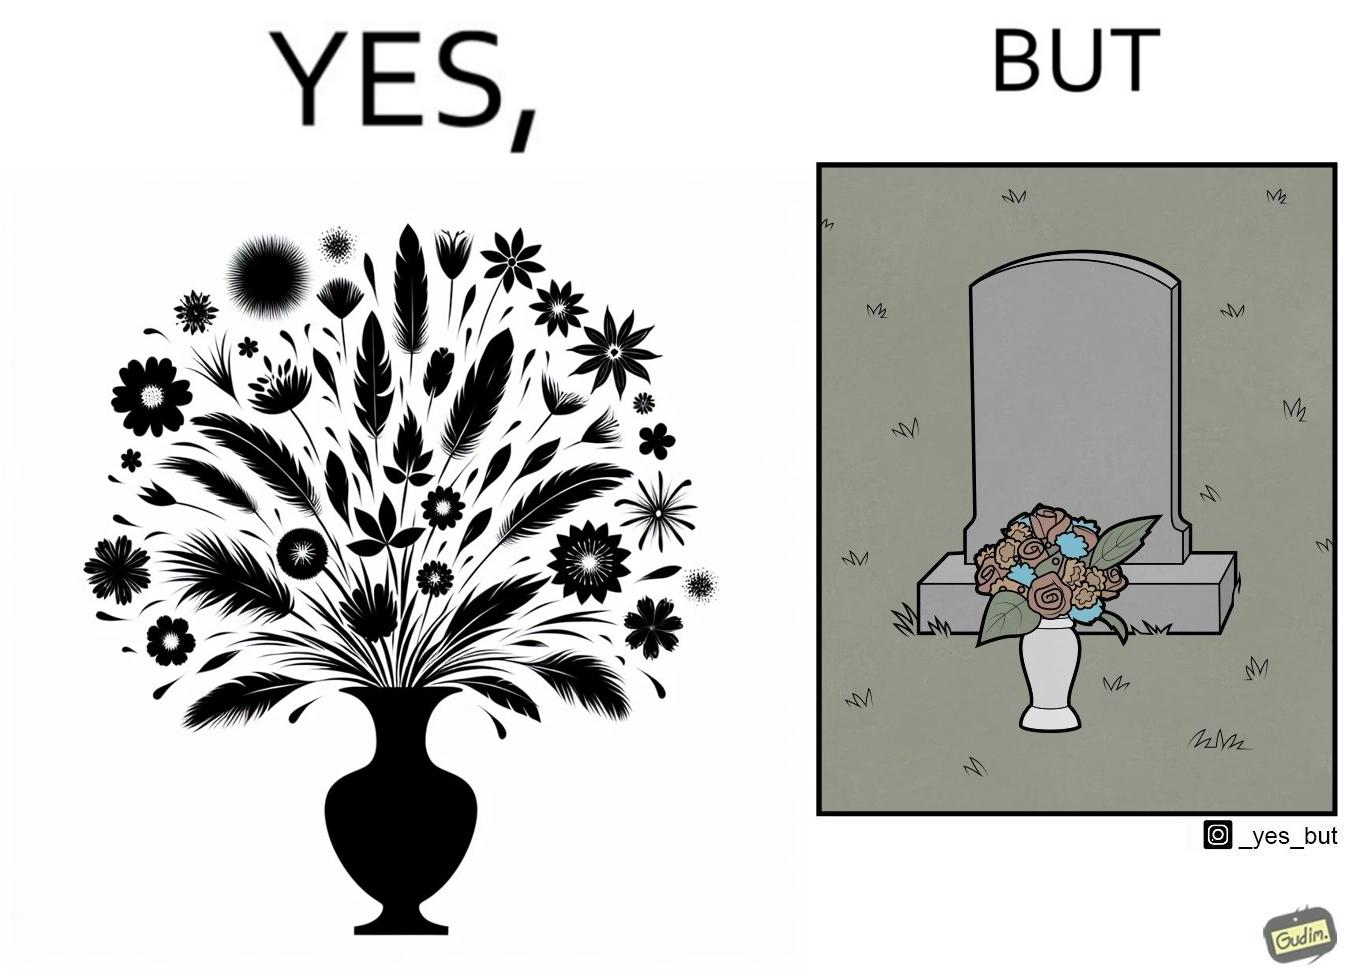Describe the satirical element in this image. The image is ironic, because in the first image a vase full of different beautiful flowers is seen which spreads a feeling of positivity, cheerfulness etc., whereas in the second image when the same vase is put in front of a grave stone it produces a feeling of sorrow 